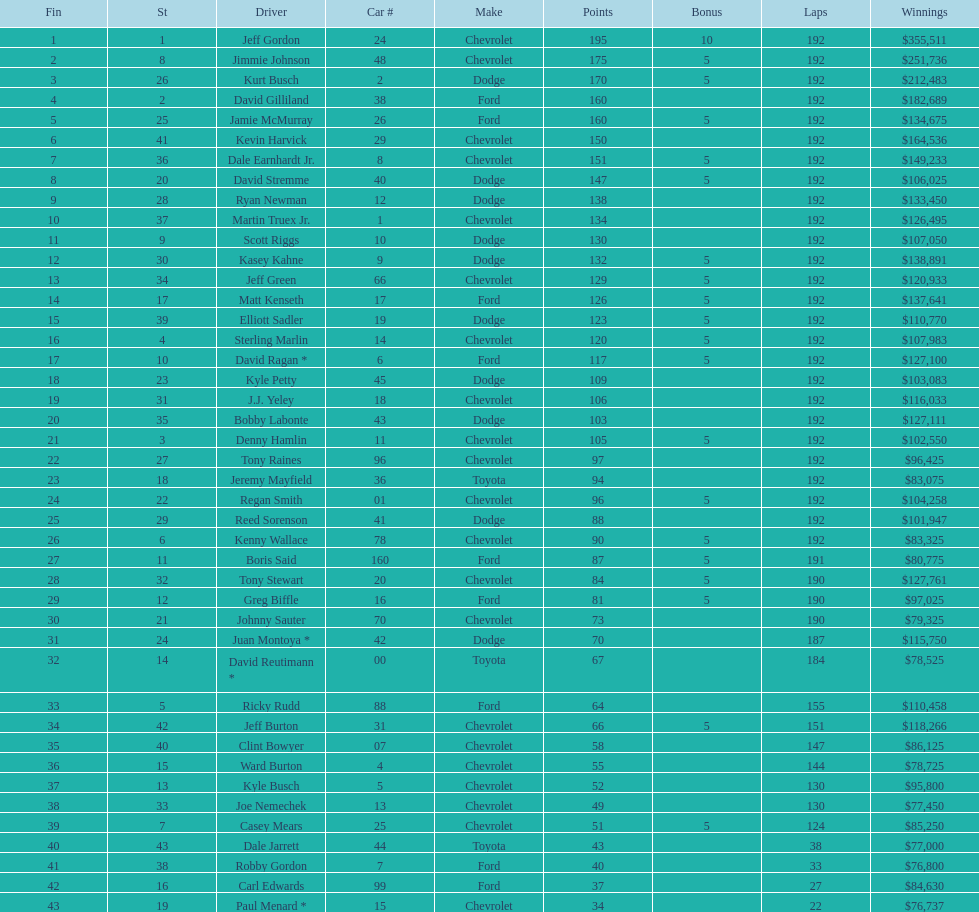For this specific race, what was the number of drivers who didn't get any bonus? 23. 